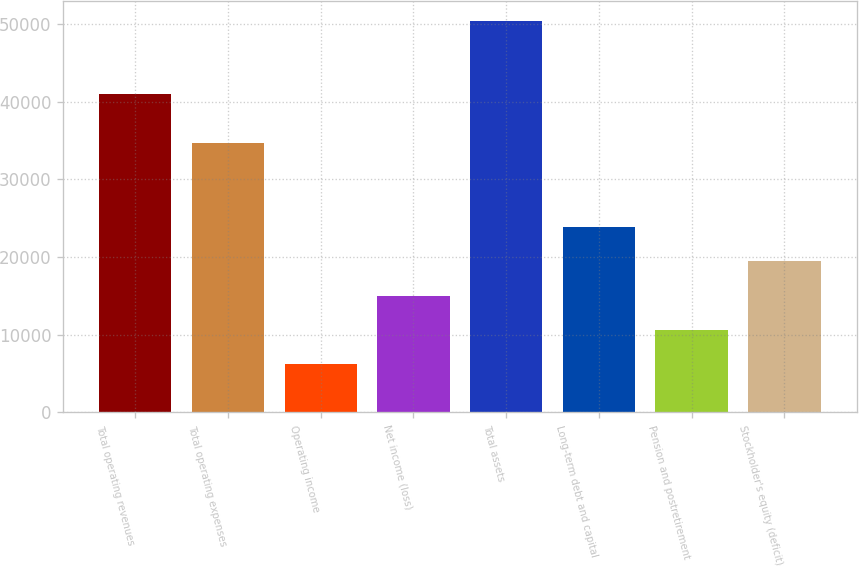Convert chart to OTSL. <chart><loc_0><loc_0><loc_500><loc_500><bar_chart><fcel>Total operating revenues<fcel>Total operating expenses<fcel>Operating income<fcel>Net income (loss)<fcel>Total assets<fcel>Long-term debt and capital<fcel>Pension and postretirement<fcel>Stockholder's equity (deficit)<nl><fcel>40938<fcel>34749<fcel>6189<fcel>15039<fcel>50439<fcel>23889<fcel>10614<fcel>19464<nl></chart> 